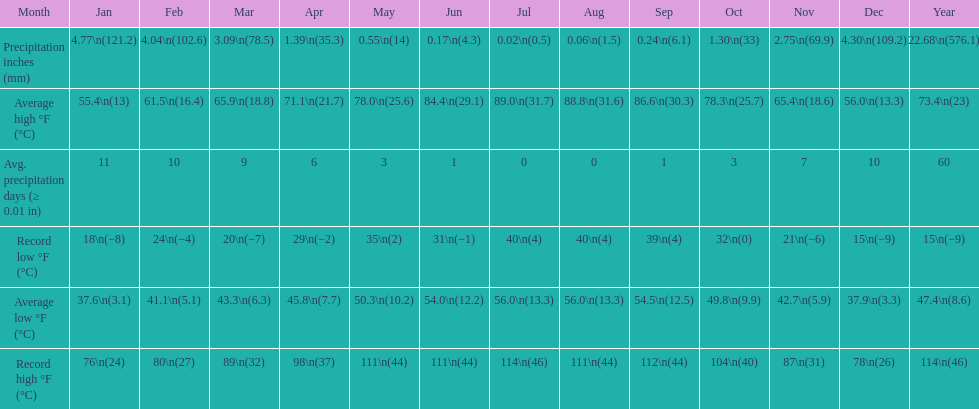How many months had a record high of 111 degrees? 3. 